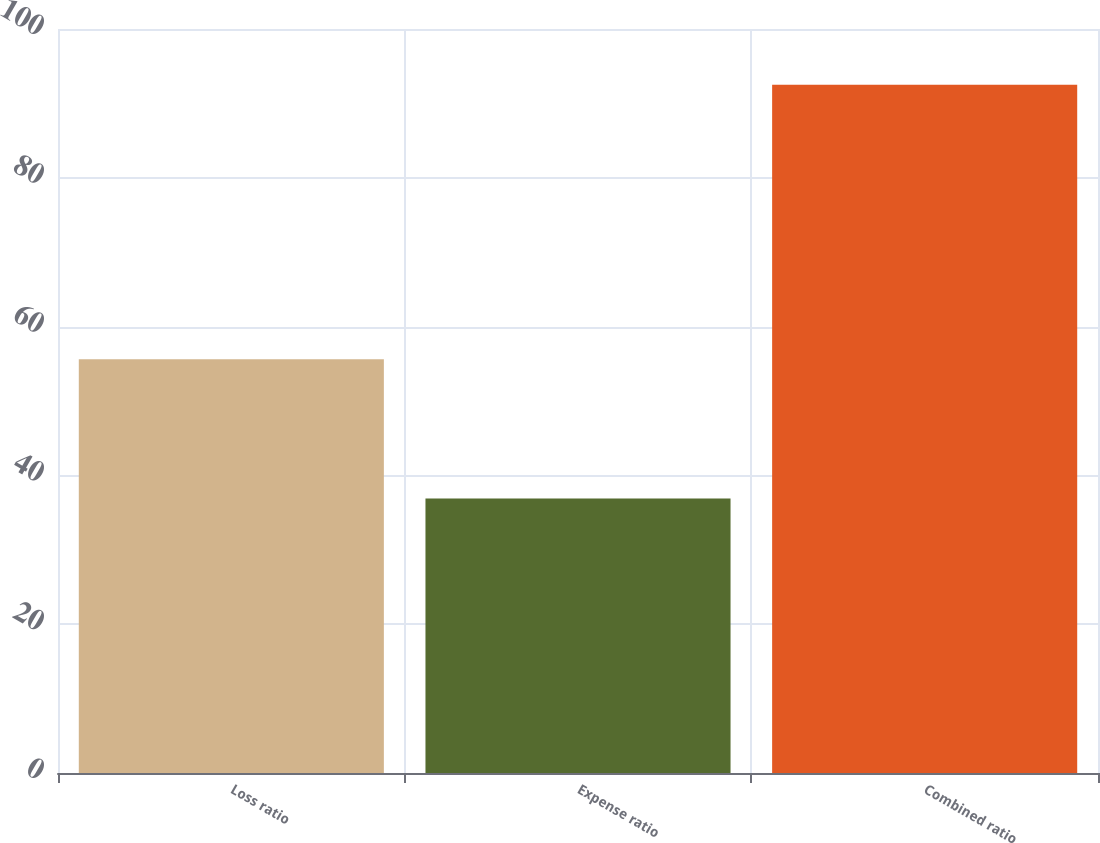<chart> <loc_0><loc_0><loc_500><loc_500><bar_chart><fcel>Loss ratio<fcel>Expense ratio<fcel>Combined ratio<nl><fcel>55.6<fcel>36.9<fcel>92.5<nl></chart> 